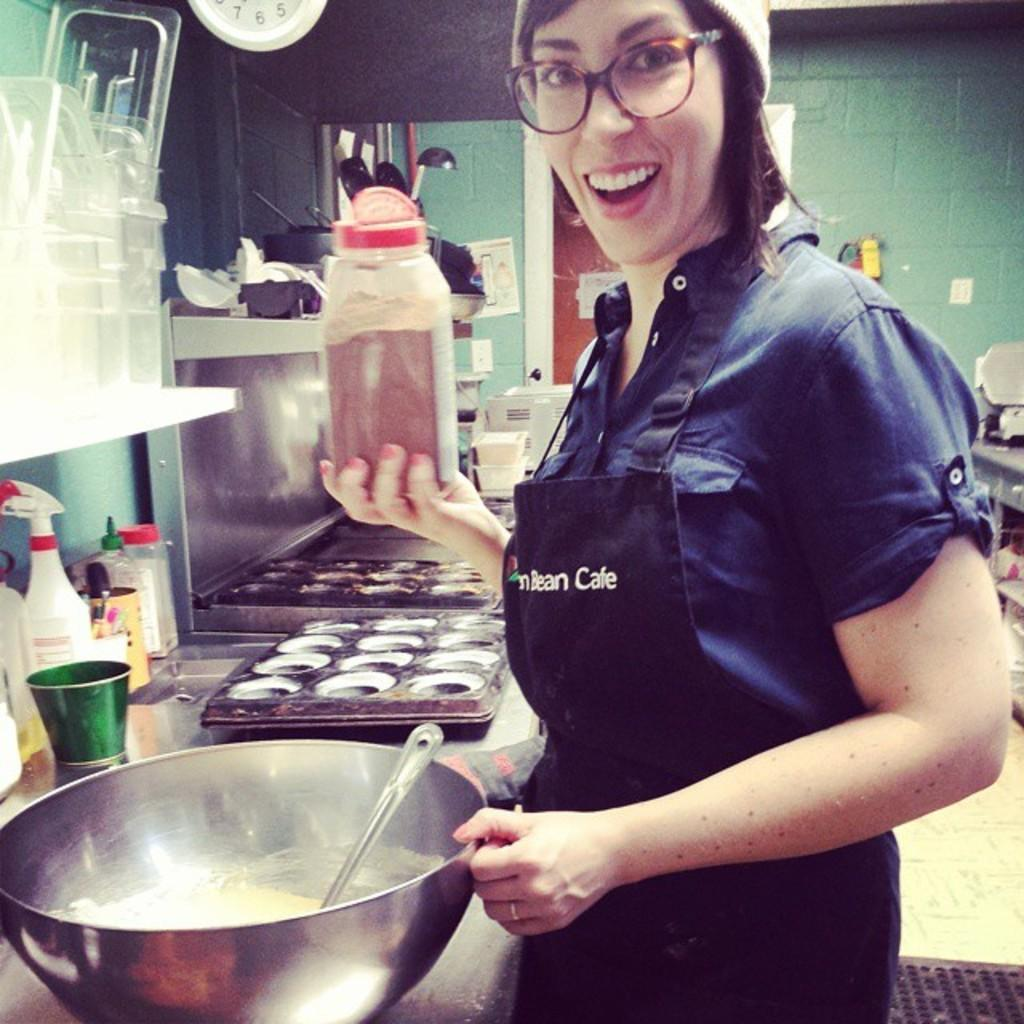What is the appearance of the woman in the image? There is a beautiful woman in the image. What expression does the woman have? The woman is smiling. What is the woman holding in her right hand? The woman is holding a box in her right hand. What is the woman wearing? The woman is wearing a dress and spectacles. What can be seen on the left side of the image? There is a big bowl on the left side of the image. What type of engine is visible in the image? There is no engine present in the image. What is the purpose of the print on the woman's dress? The woman's dress does not have a print, so there is no purpose to discuss. 